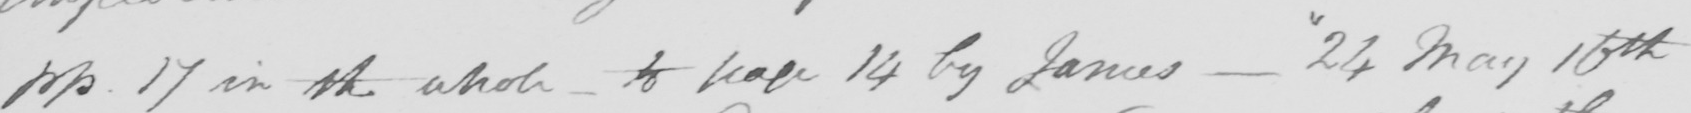Can you read and transcribe this handwriting? pp 17 in the whole to page 14 by James -  " 24 May 10th 